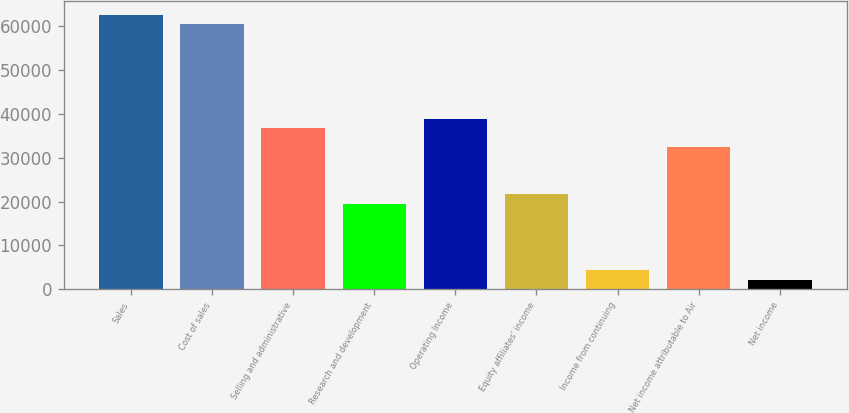Convert chart. <chart><loc_0><loc_0><loc_500><loc_500><bar_chart><fcel>Sales<fcel>Cost of sales<fcel>Selling and administrative<fcel>Research and development<fcel>Operating Income<fcel>Equity affiliates' income<fcel>Income from continuing<fcel>Net income attributable to Air<fcel>Net income<nl><fcel>62634.7<fcel>60474.9<fcel>36718<fcel>19440.2<fcel>38877.7<fcel>21600<fcel>4322.21<fcel>32398.6<fcel>2162.49<nl></chart> 